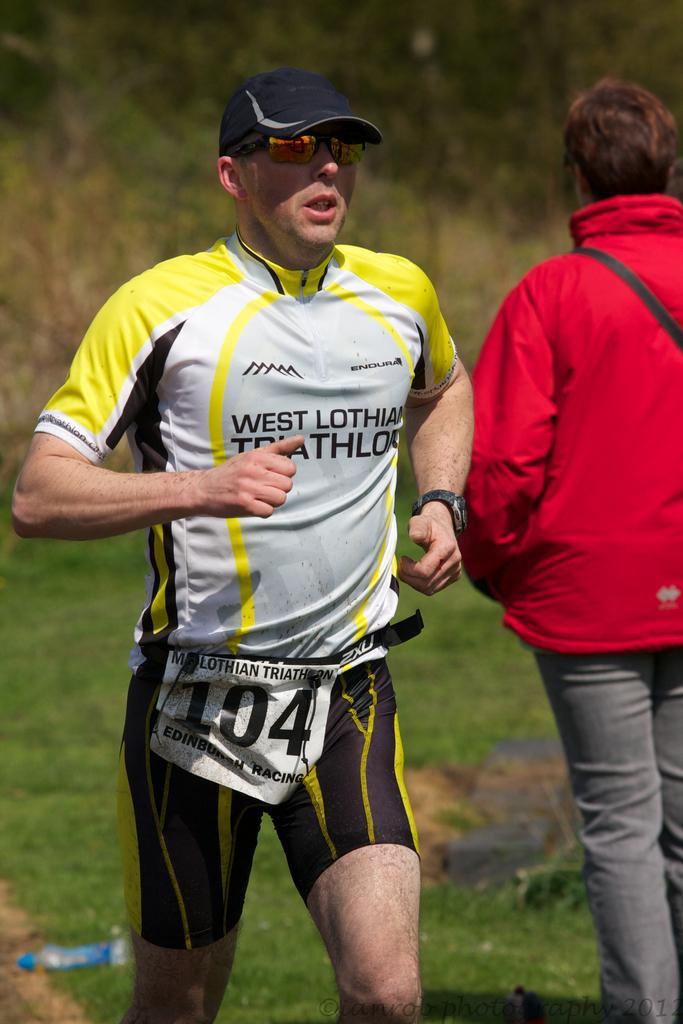How would you summarize this image in a sentence or two? In this picture we can see a man with a cap is running and on the right side of the man there is another person in the red jacket. Behind the people there are trees and grass. 